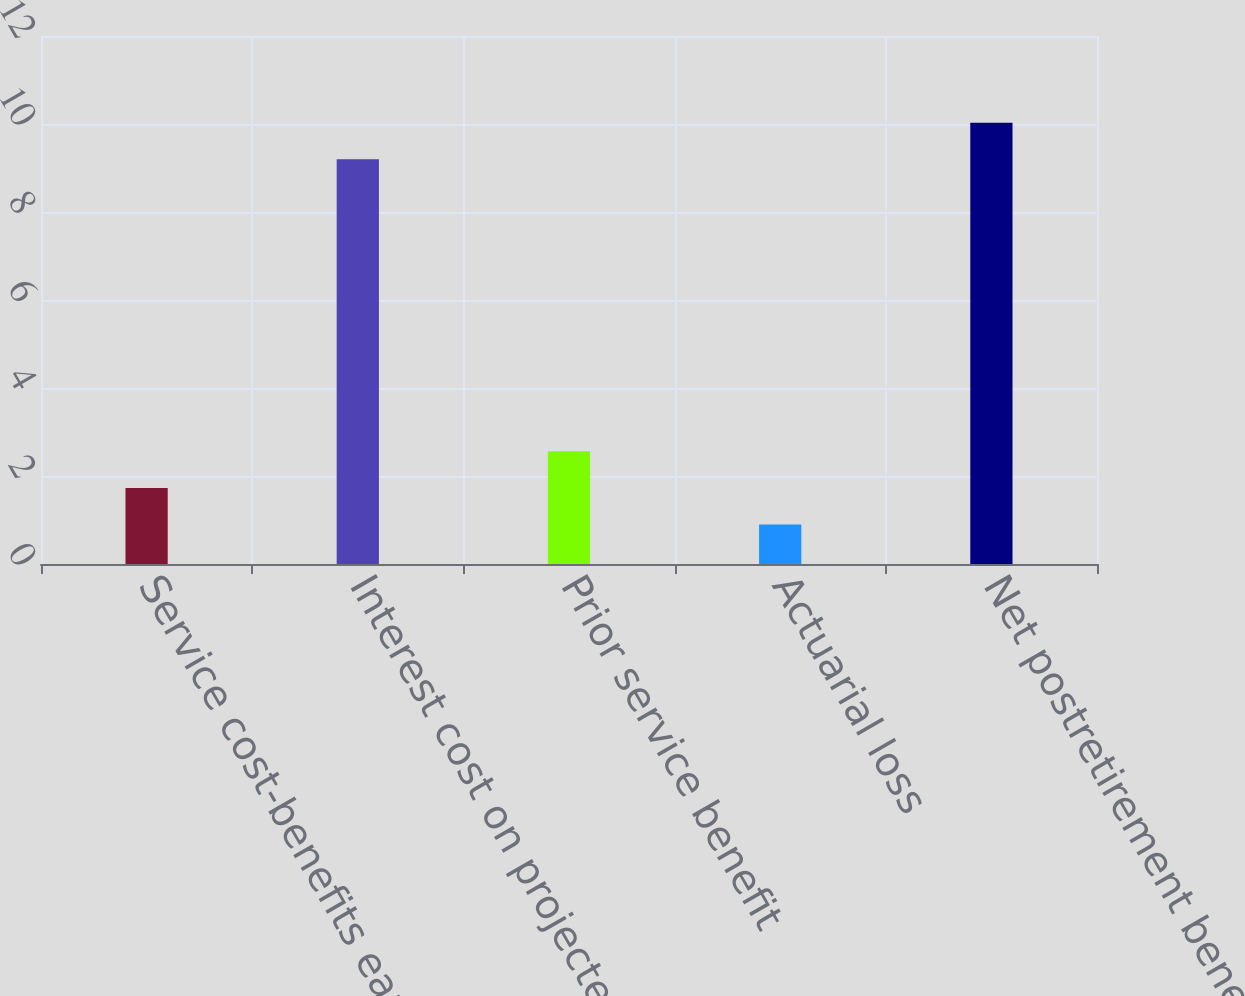Convert chart to OTSL. <chart><loc_0><loc_0><loc_500><loc_500><bar_chart><fcel>Service cost-benefits earned<fcel>Interest cost on projected<fcel>Prior service benefit<fcel>Actuarial loss<fcel>Net postretirement benefit<nl><fcel>1.73<fcel>9.2<fcel>2.56<fcel>0.9<fcel>10.03<nl></chart> 